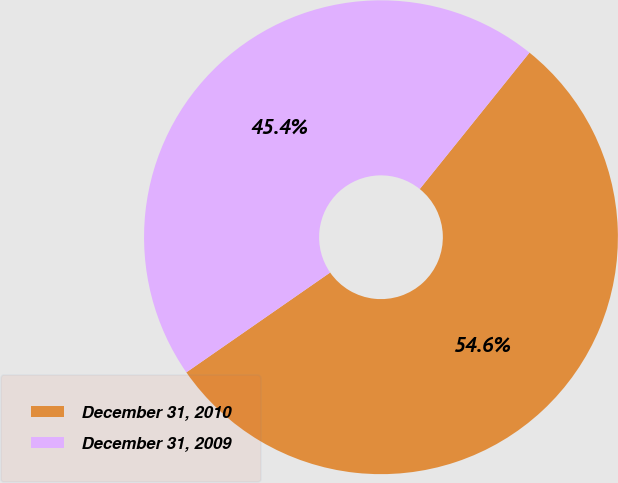Convert chart. <chart><loc_0><loc_0><loc_500><loc_500><pie_chart><fcel>December 31, 2010<fcel>December 31, 2009<nl><fcel>54.56%<fcel>45.44%<nl></chart> 